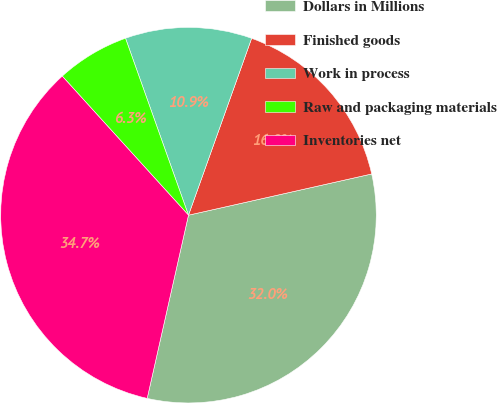<chart> <loc_0><loc_0><loc_500><loc_500><pie_chart><fcel>Dollars in Millions<fcel>Finished goods<fcel>Work in process<fcel>Raw and packaging materials<fcel>Inventories net<nl><fcel>32.05%<fcel>16.02%<fcel>10.9%<fcel>6.29%<fcel>34.74%<nl></chart> 